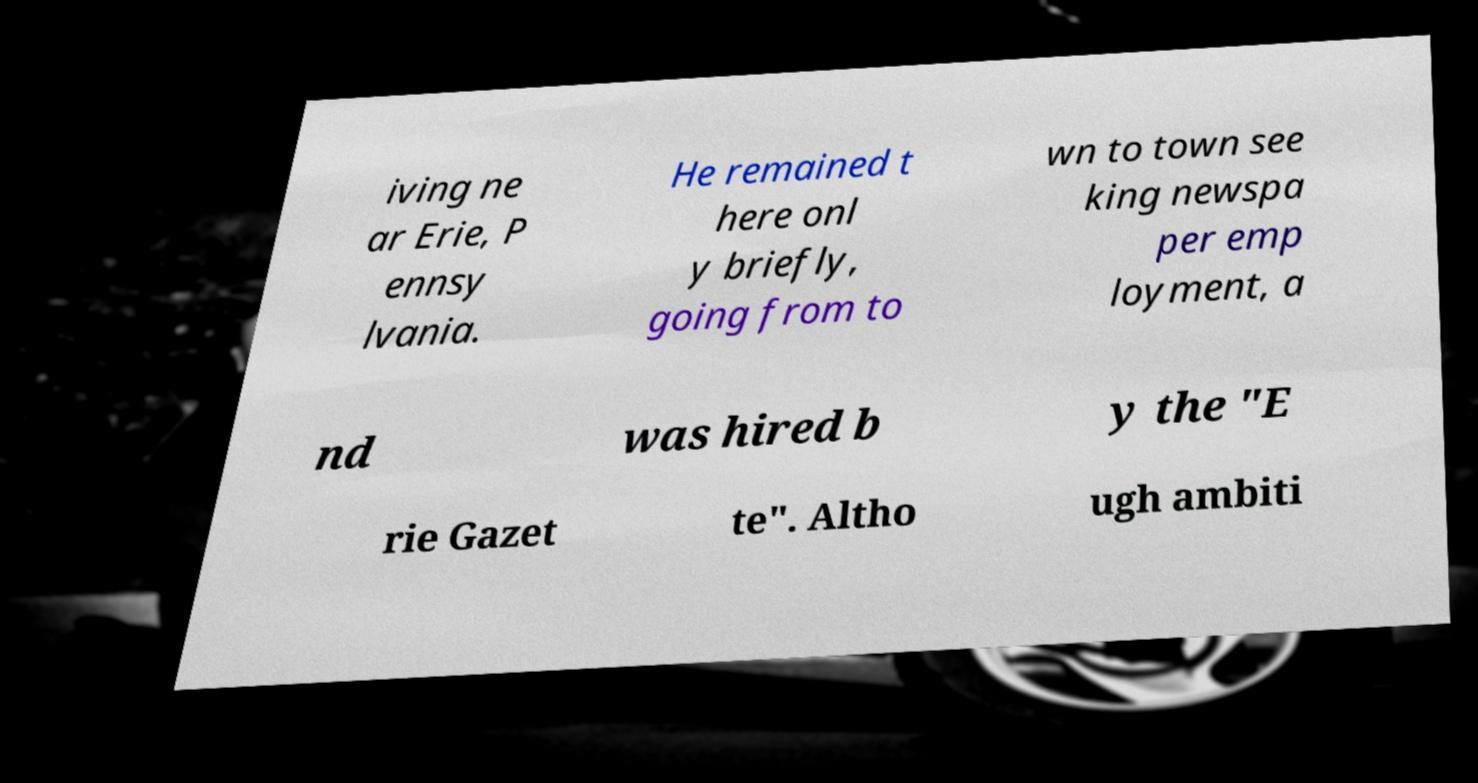I need the written content from this picture converted into text. Can you do that? iving ne ar Erie, P ennsy lvania. He remained t here onl y briefly, going from to wn to town see king newspa per emp loyment, a nd was hired b y the "E rie Gazet te". Altho ugh ambiti 